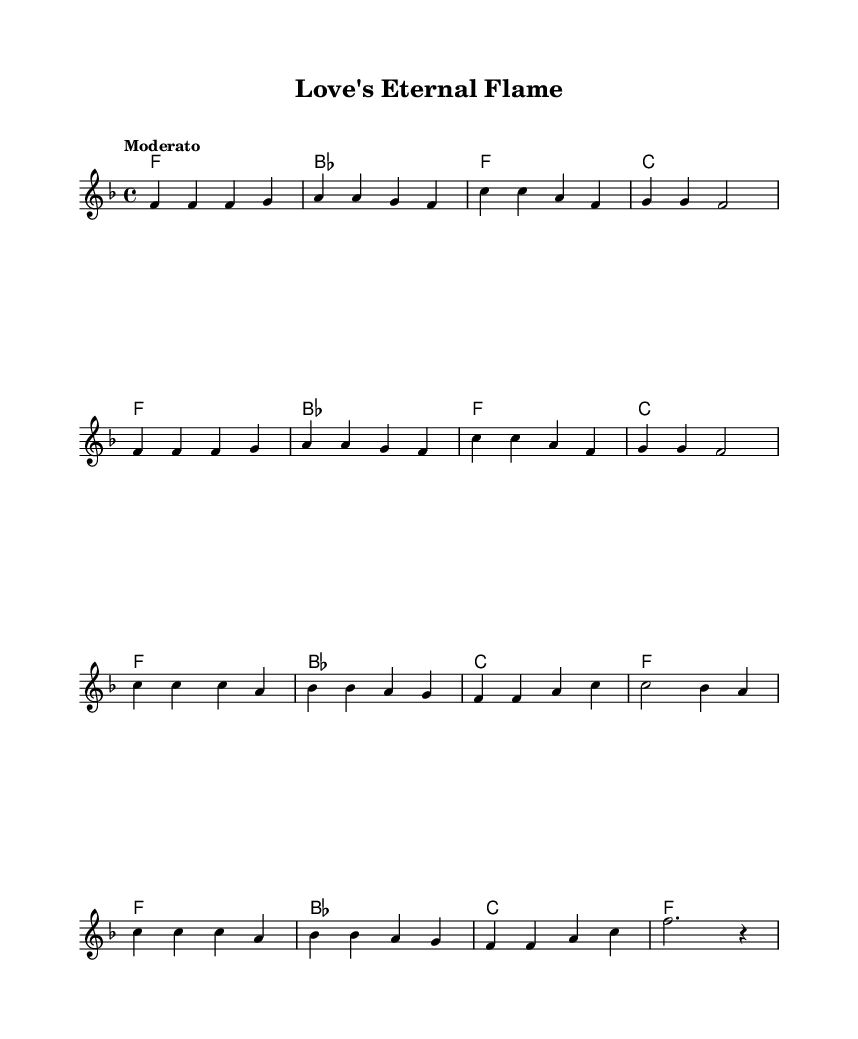What is the key signature of this music? The key signature is indicated at the beginning of the sheet music with a key signature symbol. In this piece, the symbol shows one flat, which indicates the key of F major.
Answer: F major What is the time signature of this piece? The time signature appears at the beginning and is represented by two numbers. Here, 4/4 means there are four beats in each measure and a quarter note gets one beat.
Answer: 4/4 What is the tempo marking of this piece? The tempo marking is found at the beginning and indicates how fast or slow the piece should be played. "Moderato" suggests a moderate tempo.
Answer: Moderato How many measures are in the verse section? By counting the individual measures between the repeat signs, I see that there are 8 measures in the verse section before it repeats.
Answer: 8 How many chords are used in the chorus? The chord changes can be counted directly from the chord names written in the score. I see 4 distinct chords in the chorus section: F, B flat, C, and F again.
Answer: 4 Which unique Motown feature is present in this song structure? The presence of a repeated chorus after each verse is a common Motown technique that emphasizes the emotional impact of the lyrics. This structure is pivotal in classic Motown songs.
Answer: Repeated chorus What is the final chord in the melody? The melody concludes on a specific note, which is indicated by the last note in the melody section. Here, it ends on an F note, signifying the final chord.
Answer: F 